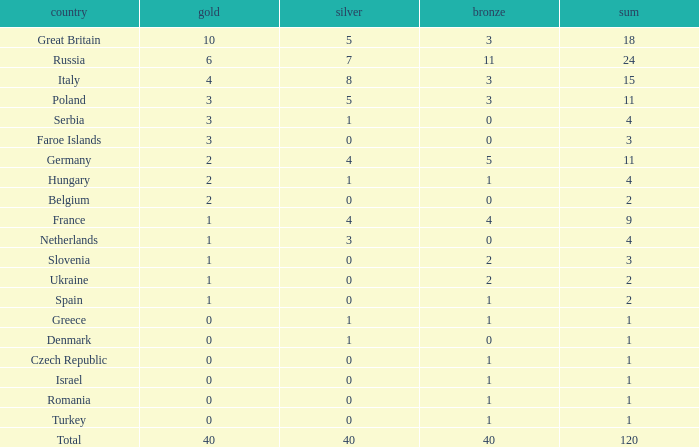What is the average Gold entry for the Netherlands that also has a Bronze entry that is greater than 0? None. Help me parse the entirety of this table. {'header': ['country', 'gold', 'silver', 'bronze', 'sum'], 'rows': [['Great Britain', '10', '5', '3', '18'], ['Russia', '6', '7', '11', '24'], ['Italy', '4', '8', '3', '15'], ['Poland', '3', '5', '3', '11'], ['Serbia', '3', '1', '0', '4'], ['Faroe Islands', '3', '0', '0', '3'], ['Germany', '2', '4', '5', '11'], ['Hungary', '2', '1', '1', '4'], ['Belgium', '2', '0', '0', '2'], ['France', '1', '4', '4', '9'], ['Netherlands', '1', '3', '0', '4'], ['Slovenia', '1', '0', '2', '3'], ['Ukraine', '1', '0', '2', '2'], ['Spain', '1', '0', '1', '2'], ['Greece', '0', '1', '1', '1'], ['Denmark', '0', '1', '0', '1'], ['Czech Republic', '0', '0', '1', '1'], ['Israel', '0', '0', '1', '1'], ['Romania', '0', '0', '1', '1'], ['Turkey', '0', '0', '1', '1'], ['Total', '40', '40', '40', '120']]} 